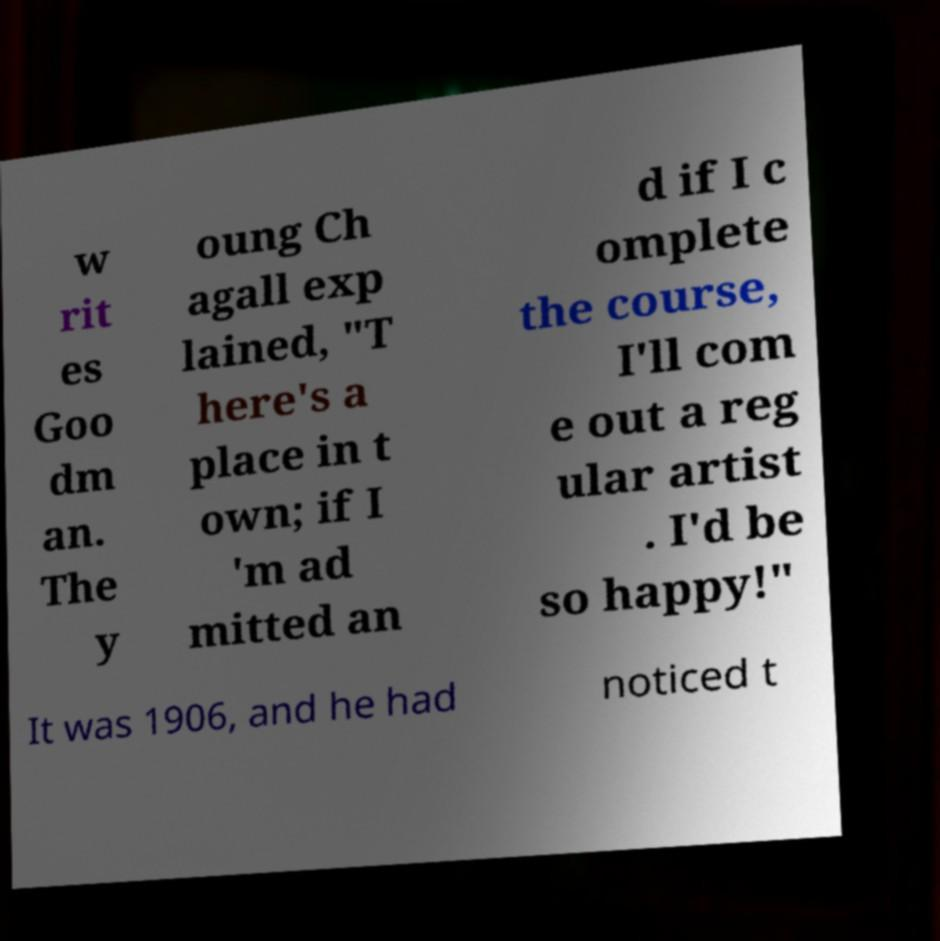I need the written content from this picture converted into text. Can you do that? w rit es Goo dm an. The y oung Ch agall exp lained, "T here's a place in t own; if I 'm ad mitted an d if I c omplete the course, I'll com e out a reg ular artist . I'd be so happy!" It was 1906, and he had noticed t 